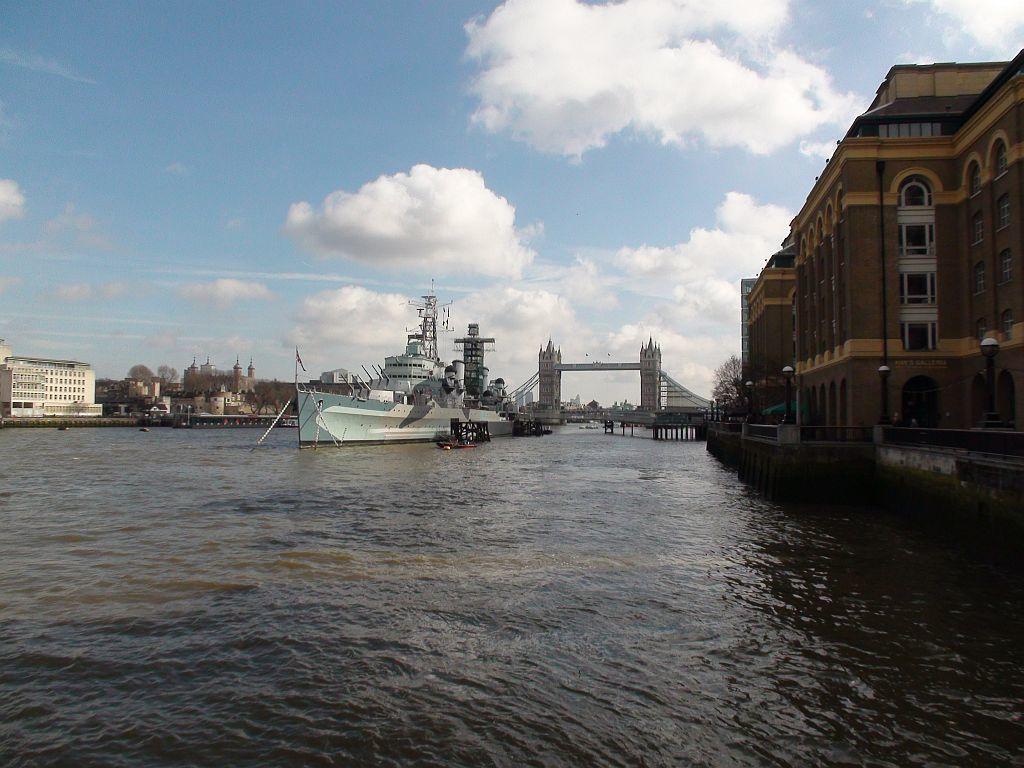Can you describe this image briefly? In this picture we can see a ship in water. There are few buildings and trees in the background. Sky is blue in color and cloudy. 